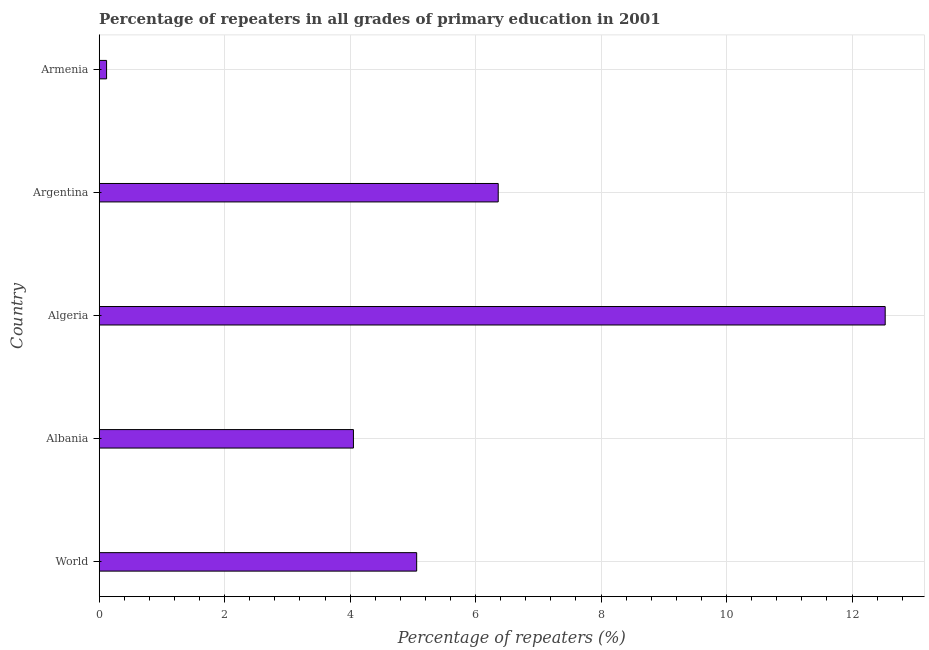Does the graph contain grids?
Make the answer very short. Yes. What is the title of the graph?
Make the answer very short. Percentage of repeaters in all grades of primary education in 2001. What is the label or title of the X-axis?
Give a very brief answer. Percentage of repeaters (%). What is the percentage of repeaters in primary education in Albania?
Ensure brevity in your answer.  4.05. Across all countries, what is the maximum percentage of repeaters in primary education?
Ensure brevity in your answer.  12.53. Across all countries, what is the minimum percentage of repeaters in primary education?
Make the answer very short. 0.12. In which country was the percentage of repeaters in primary education maximum?
Ensure brevity in your answer.  Algeria. In which country was the percentage of repeaters in primary education minimum?
Provide a succinct answer. Armenia. What is the sum of the percentage of repeaters in primary education?
Provide a short and direct response. 28.12. What is the difference between the percentage of repeaters in primary education in Albania and World?
Make the answer very short. -1.01. What is the average percentage of repeaters in primary education per country?
Offer a very short reply. 5.62. What is the median percentage of repeaters in primary education?
Ensure brevity in your answer.  5.06. What is the ratio of the percentage of repeaters in primary education in Albania to that in Argentina?
Ensure brevity in your answer.  0.64. Is the difference between the percentage of repeaters in primary education in Albania and Armenia greater than the difference between any two countries?
Keep it short and to the point. No. What is the difference between the highest and the second highest percentage of repeaters in primary education?
Offer a very short reply. 6.17. What is the difference between the highest and the lowest percentage of repeaters in primary education?
Your response must be concise. 12.41. In how many countries, is the percentage of repeaters in primary education greater than the average percentage of repeaters in primary education taken over all countries?
Ensure brevity in your answer.  2. Are all the bars in the graph horizontal?
Your answer should be very brief. Yes. Are the values on the major ticks of X-axis written in scientific E-notation?
Provide a short and direct response. No. What is the Percentage of repeaters (%) in World?
Offer a very short reply. 5.06. What is the Percentage of repeaters (%) in Albania?
Provide a succinct answer. 4.05. What is the Percentage of repeaters (%) in Algeria?
Your response must be concise. 12.53. What is the Percentage of repeaters (%) in Argentina?
Provide a short and direct response. 6.36. What is the Percentage of repeaters (%) in Armenia?
Ensure brevity in your answer.  0.12. What is the difference between the Percentage of repeaters (%) in World and Albania?
Provide a short and direct response. 1.01. What is the difference between the Percentage of repeaters (%) in World and Algeria?
Your answer should be compact. -7.47. What is the difference between the Percentage of repeaters (%) in World and Argentina?
Ensure brevity in your answer.  -1.3. What is the difference between the Percentage of repeaters (%) in World and Armenia?
Provide a succinct answer. 4.94. What is the difference between the Percentage of repeaters (%) in Albania and Algeria?
Offer a terse response. -8.48. What is the difference between the Percentage of repeaters (%) in Albania and Argentina?
Offer a terse response. -2.31. What is the difference between the Percentage of repeaters (%) in Albania and Armenia?
Ensure brevity in your answer.  3.93. What is the difference between the Percentage of repeaters (%) in Algeria and Argentina?
Your response must be concise. 6.17. What is the difference between the Percentage of repeaters (%) in Algeria and Armenia?
Your answer should be compact. 12.41. What is the difference between the Percentage of repeaters (%) in Argentina and Armenia?
Offer a terse response. 6.24. What is the ratio of the Percentage of repeaters (%) in World to that in Albania?
Provide a succinct answer. 1.25. What is the ratio of the Percentage of repeaters (%) in World to that in Algeria?
Offer a terse response. 0.4. What is the ratio of the Percentage of repeaters (%) in World to that in Argentina?
Keep it short and to the point. 0.8. What is the ratio of the Percentage of repeaters (%) in World to that in Armenia?
Your answer should be compact. 43.1. What is the ratio of the Percentage of repeaters (%) in Albania to that in Algeria?
Make the answer very short. 0.32. What is the ratio of the Percentage of repeaters (%) in Albania to that in Argentina?
Give a very brief answer. 0.64. What is the ratio of the Percentage of repeaters (%) in Albania to that in Armenia?
Keep it short and to the point. 34.52. What is the ratio of the Percentage of repeaters (%) in Algeria to that in Argentina?
Offer a terse response. 1.97. What is the ratio of the Percentage of repeaters (%) in Algeria to that in Armenia?
Give a very brief answer. 106.71. What is the ratio of the Percentage of repeaters (%) in Argentina to that in Armenia?
Your response must be concise. 54.17. 